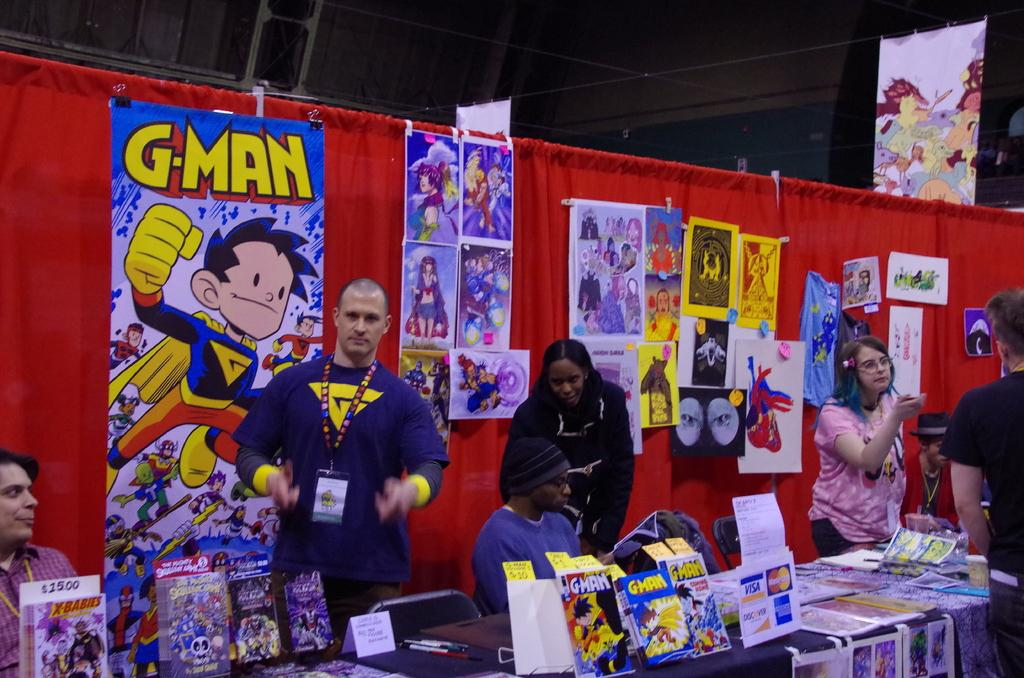Provide a one-sentence caption for the provided image. G Man comic books and magazines on a table at a convention. 